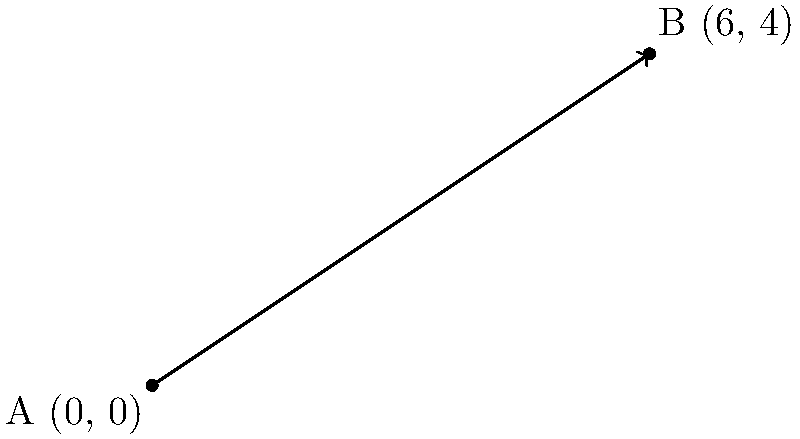The roof of our beloved country chapel forms a straight line when viewed from the side. The edge of the roof starts at point A (0, 0) and ends at point B (6, 4), as shown in the diagram. Calculate the slope of the chapel's roof line, which represents its steepness. Round your answer to two decimal places if necessary. To find the slope of the line representing the chapel's roof, we can use the slope formula:

$$ \text{Slope} = \frac{\text{rise}}{\text{run}} = \frac{y_2 - y_1}{x_2 - x_1} $$

Where $(x_1, y_1)$ is the first point and $(x_2, y_2)$ is the second point.

Given:
- Point A: $(0, 0)$
- Point B: $(6, 4)$

Let's plug these values into the formula:

$$ \text{Slope} = \frac{4 - 0}{6 - 0} = \frac{4}{6} $$

Simplifying the fraction:

$$ \frac{4}{6} = \frac{2}{3} \approx 0.67 $$

The slope of the chapel's roof line is $\frac{2}{3}$ or approximately 0.67.

This means for every 3 units the roof extends horizontally, it rises 2 units vertically.
Answer: $\frac{2}{3}$ or 0.67 